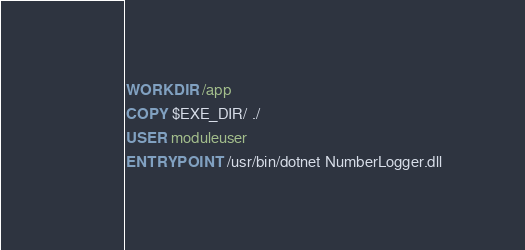Convert code to text. <code><loc_0><loc_0><loc_500><loc_500><_Dockerfile_>WORKDIR /app

COPY $EXE_DIR/ ./

USER moduleuser

ENTRYPOINT /usr/bin/dotnet NumberLogger.dll
</code> 